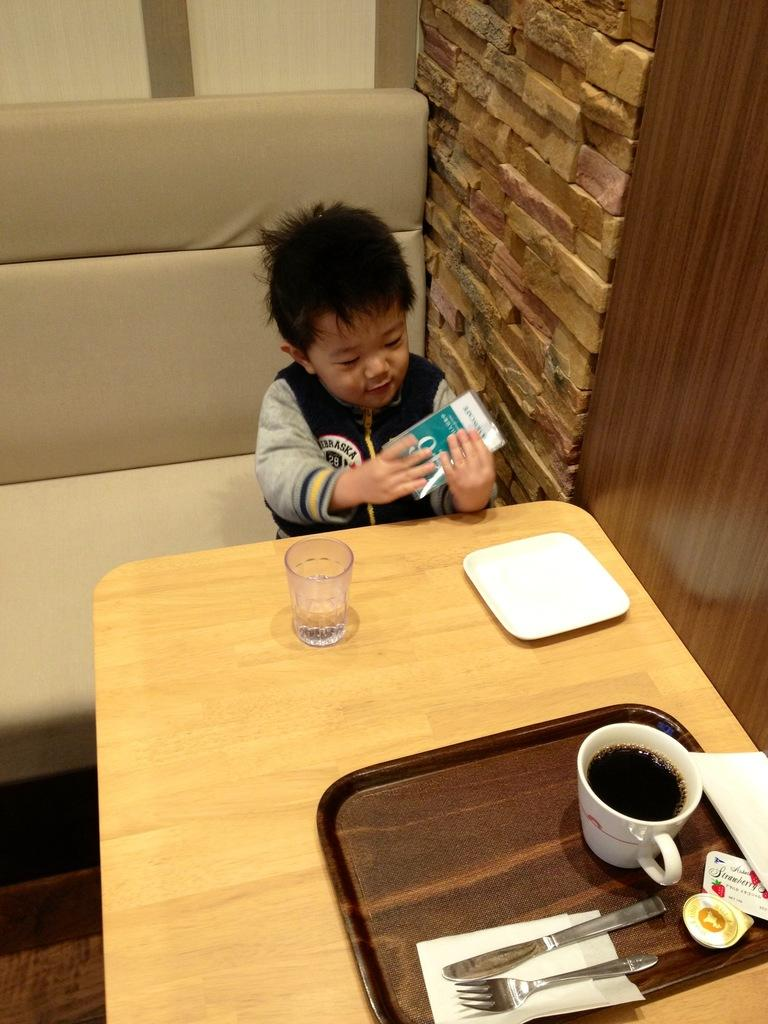Who is present in the image? There is a boy in the image. What is the boy holding? The boy is holding a pack. Where is the boy sitting? The boy is sitting at a table. What objects are on the table? There is a plate, a glass, and a coffee cup on the table. Can you see any alleys in the image? There are no alleys present in the image; it features a boy sitting at a table with various objects. Are there any bees buzzing around the coffee cup in the image? There are no bees present in the image; it only shows a boy, a pack, and objects on a table. 